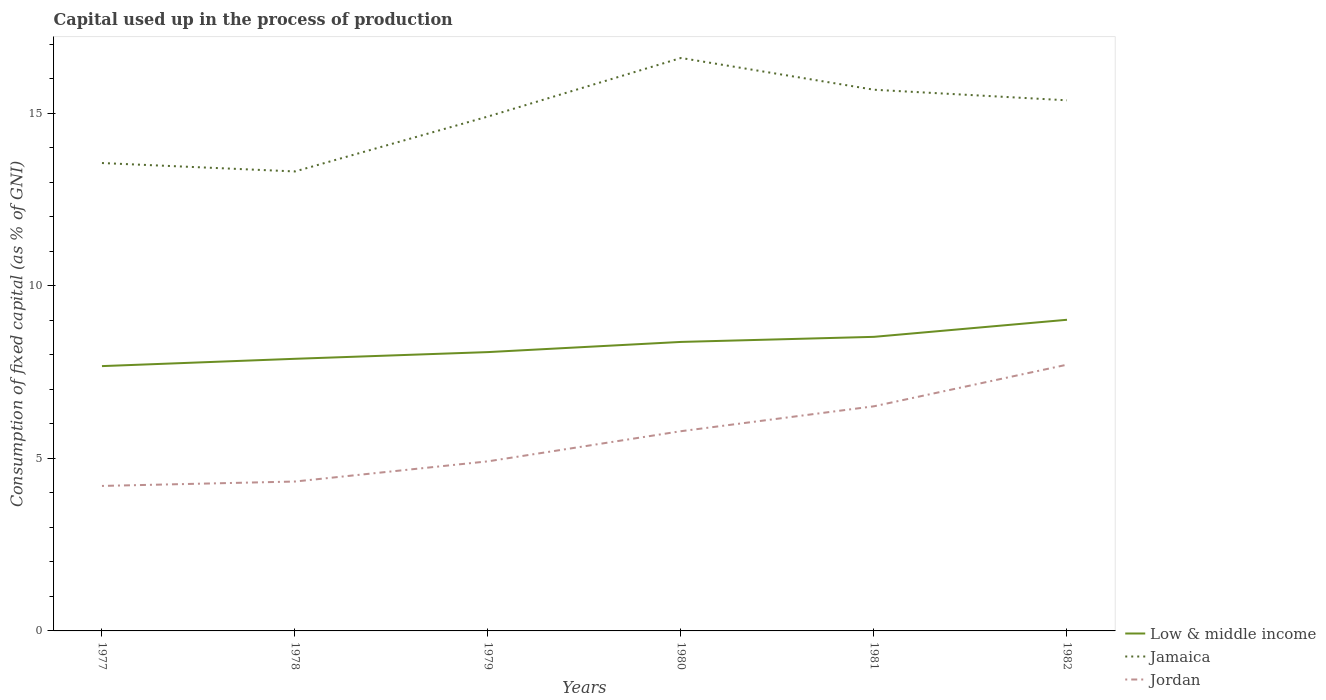Does the line corresponding to Jordan intersect with the line corresponding to Jamaica?
Your answer should be very brief. No. Across all years, what is the maximum capital used up in the process of production in Jamaica?
Offer a very short reply. 13.31. In which year was the capital used up in the process of production in Jamaica maximum?
Provide a succinct answer. 1978. What is the total capital used up in the process of production in Jordan in the graph?
Your answer should be very brief. -1.59. What is the difference between the highest and the second highest capital used up in the process of production in Low & middle income?
Provide a short and direct response. 1.34. What is the difference between the highest and the lowest capital used up in the process of production in Low & middle income?
Provide a succinct answer. 3. Is the capital used up in the process of production in Jamaica strictly greater than the capital used up in the process of production in Jordan over the years?
Provide a short and direct response. No. What is the difference between two consecutive major ticks on the Y-axis?
Provide a succinct answer. 5. Are the values on the major ticks of Y-axis written in scientific E-notation?
Provide a short and direct response. No. Does the graph contain grids?
Provide a short and direct response. No. Where does the legend appear in the graph?
Provide a succinct answer. Bottom right. How are the legend labels stacked?
Give a very brief answer. Vertical. What is the title of the graph?
Offer a very short reply. Capital used up in the process of production. Does "Thailand" appear as one of the legend labels in the graph?
Keep it short and to the point. No. What is the label or title of the X-axis?
Make the answer very short. Years. What is the label or title of the Y-axis?
Provide a short and direct response. Consumption of fixed capital (as % of GNI). What is the Consumption of fixed capital (as % of GNI) of Low & middle income in 1977?
Ensure brevity in your answer.  7.67. What is the Consumption of fixed capital (as % of GNI) in Jamaica in 1977?
Give a very brief answer. 13.55. What is the Consumption of fixed capital (as % of GNI) of Jordan in 1977?
Offer a very short reply. 4.2. What is the Consumption of fixed capital (as % of GNI) in Low & middle income in 1978?
Provide a short and direct response. 7.88. What is the Consumption of fixed capital (as % of GNI) in Jamaica in 1978?
Your response must be concise. 13.31. What is the Consumption of fixed capital (as % of GNI) of Jordan in 1978?
Your answer should be compact. 4.33. What is the Consumption of fixed capital (as % of GNI) in Low & middle income in 1979?
Your answer should be compact. 8.08. What is the Consumption of fixed capital (as % of GNI) of Jamaica in 1979?
Your answer should be compact. 14.9. What is the Consumption of fixed capital (as % of GNI) of Jordan in 1979?
Offer a very short reply. 4.91. What is the Consumption of fixed capital (as % of GNI) in Low & middle income in 1980?
Your answer should be very brief. 8.37. What is the Consumption of fixed capital (as % of GNI) of Jamaica in 1980?
Your answer should be very brief. 16.6. What is the Consumption of fixed capital (as % of GNI) of Jordan in 1980?
Ensure brevity in your answer.  5.79. What is the Consumption of fixed capital (as % of GNI) in Low & middle income in 1981?
Your response must be concise. 8.52. What is the Consumption of fixed capital (as % of GNI) of Jamaica in 1981?
Offer a terse response. 15.68. What is the Consumption of fixed capital (as % of GNI) of Jordan in 1981?
Provide a succinct answer. 6.51. What is the Consumption of fixed capital (as % of GNI) in Low & middle income in 1982?
Ensure brevity in your answer.  9.01. What is the Consumption of fixed capital (as % of GNI) of Jamaica in 1982?
Your response must be concise. 15.37. What is the Consumption of fixed capital (as % of GNI) of Jordan in 1982?
Your response must be concise. 7.71. Across all years, what is the maximum Consumption of fixed capital (as % of GNI) in Low & middle income?
Provide a short and direct response. 9.01. Across all years, what is the maximum Consumption of fixed capital (as % of GNI) of Jamaica?
Ensure brevity in your answer.  16.6. Across all years, what is the maximum Consumption of fixed capital (as % of GNI) of Jordan?
Your answer should be compact. 7.71. Across all years, what is the minimum Consumption of fixed capital (as % of GNI) of Low & middle income?
Your answer should be compact. 7.67. Across all years, what is the minimum Consumption of fixed capital (as % of GNI) of Jamaica?
Ensure brevity in your answer.  13.31. Across all years, what is the minimum Consumption of fixed capital (as % of GNI) in Jordan?
Make the answer very short. 4.2. What is the total Consumption of fixed capital (as % of GNI) of Low & middle income in the graph?
Your answer should be very brief. 49.53. What is the total Consumption of fixed capital (as % of GNI) in Jamaica in the graph?
Offer a very short reply. 89.41. What is the total Consumption of fixed capital (as % of GNI) in Jordan in the graph?
Offer a very short reply. 33.44. What is the difference between the Consumption of fixed capital (as % of GNI) of Low & middle income in 1977 and that in 1978?
Keep it short and to the point. -0.21. What is the difference between the Consumption of fixed capital (as % of GNI) of Jamaica in 1977 and that in 1978?
Provide a succinct answer. 0.24. What is the difference between the Consumption of fixed capital (as % of GNI) in Jordan in 1977 and that in 1978?
Provide a short and direct response. -0.13. What is the difference between the Consumption of fixed capital (as % of GNI) of Low & middle income in 1977 and that in 1979?
Offer a very short reply. -0.41. What is the difference between the Consumption of fixed capital (as % of GNI) of Jamaica in 1977 and that in 1979?
Make the answer very short. -1.35. What is the difference between the Consumption of fixed capital (as % of GNI) of Jordan in 1977 and that in 1979?
Make the answer very short. -0.71. What is the difference between the Consumption of fixed capital (as % of GNI) of Low & middle income in 1977 and that in 1980?
Your response must be concise. -0.7. What is the difference between the Consumption of fixed capital (as % of GNI) in Jamaica in 1977 and that in 1980?
Your answer should be compact. -3.04. What is the difference between the Consumption of fixed capital (as % of GNI) of Jordan in 1977 and that in 1980?
Your answer should be very brief. -1.59. What is the difference between the Consumption of fixed capital (as % of GNI) in Low & middle income in 1977 and that in 1981?
Keep it short and to the point. -0.85. What is the difference between the Consumption of fixed capital (as % of GNI) of Jamaica in 1977 and that in 1981?
Your answer should be compact. -2.12. What is the difference between the Consumption of fixed capital (as % of GNI) in Jordan in 1977 and that in 1981?
Make the answer very short. -2.31. What is the difference between the Consumption of fixed capital (as % of GNI) in Low & middle income in 1977 and that in 1982?
Your response must be concise. -1.34. What is the difference between the Consumption of fixed capital (as % of GNI) of Jamaica in 1977 and that in 1982?
Provide a short and direct response. -1.82. What is the difference between the Consumption of fixed capital (as % of GNI) in Jordan in 1977 and that in 1982?
Make the answer very short. -3.51. What is the difference between the Consumption of fixed capital (as % of GNI) in Low & middle income in 1978 and that in 1979?
Provide a succinct answer. -0.19. What is the difference between the Consumption of fixed capital (as % of GNI) in Jamaica in 1978 and that in 1979?
Keep it short and to the point. -1.59. What is the difference between the Consumption of fixed capital (as % of GNI) of Jordan in 1978 and that in 1979?
Offer a very short reply. -0.58. What is the difference between the Consumption of fixed capital (as % of GNI) in Low & middle income in 1978 and that in 1980?
Provide a succinct answer. -0.49. What is the difference between the Consumption of fixed capital (as % of GNI) of Jamaica in 1978 and that in 1980?
Provide a succinct answer. -3.29. What is the difference between the Consumption of fixed capital (as % of GNI) of Jordan in 1978 and that in 1980?
Provide a short and direct response. -1.46. What is the difference between the Consumption of fixed capital (as % of GNI) of Low & middle income in 1978 and that in 1981?
Give a very brief answer. -0.64. What is the difference between the Consumption of fixed capital (as % of GNI) in Jamaica in 1978 and that in 1981?
Make the answer very short. -2.37. What is the difference between the Consumption of fixed capital (as % of GNI) in Jordan in 1978 and that in 1981?
Your answer should be very brief. -2.18. What is the difference between the Consumption of fixed capital (as % of GNI) in Low & middle income in 1978 and that in 1982?
Offer a very short reply. -1.13. What is the difference between the Consumption of fixed capital (as % of GNI) in Jamaica in 1978 and that in 1982?
Offer a terse response. -2.06. What is the difference between the Consumption of fixed capital (as % of GNI) in Jordan in 1978 and that in 1982?
Your answer should be very brief. -3.38. What is the difference between the Consumption of fixed capital (as % of GNI) in Low & middle income in 1979 and that in 1980?
Offer a very short reply. -0.29. What is the difference between the Consumption of fixed capital (as % of GNI) in Jamaica in 1979 and that in 1980?
Your response must be concise. -1.7. What is the difference between the Consumption of fixed capital (as % of GNI) of Jordan in 1979 and that in 1980?
Provide a succinct answer. -0.87. What is the difference between the Consumption of fixed capital (as % of GNI) of Low & middle income in 1979 and that in 1981?
Your answer should be very brief. -0.44. What is the difference between the Consumption of fixed capital (as % of GNI) of Jamaica in 1979 and that in 1981?
Your answer should be very brief. -0.78. What is the difference between the Consumption of fixed capital (as % of GNI) in Jordan in 1979 and that in 1981?
Your answer should be compact. -1.59. What is the difference between the Consumption of fixed capital (as % of GNI) in Low & middle income in 1979 and that in 1982?
Provide a succinct answer. -0.94. What is the difference between the Consumption of fixed capital (as % of GNI) of Jamaica in 1979 and that in 1982?
Offer a very short reply. -0.47. What is the difference between the Consumption of fixed capital (as % of GNI) in Jordan in 1979 and that in 1982?
Keep it short and to the point. -2.8. What is the difference between the Consumption of fixed capital (as % of GNI) in Low & middle income in 1980 and that in 1981?
Offer a terse response. -0.15. What is the difference between the Consumption of fixed capital (as % of GNI) of Jamaica in 1980 and that in 1981?
Your response must be concise. 0.92. What is the difference between the Consumption of fixed capital (as % of GNI) of Jordan in 1980 and that in 1981?
Your answer should be compact. -0.72. What is the difference between the Consumption of fixed capital (as % of GNI) in Low & middle income in 1980 and that in 1982?
Make the answer very short. -0.64. What is the difference between the Consumption of fixed capital (as % of GNI) of Jamaica in 1980 and that in 1982?
Offer a terse response. 1.23. What is the difference between the Consumption of fixed capital (as % of GNI) in Jordan in 1980 and that in 1982?
Offer a terse response. -1.93. What is the difference between the Consumption of fixed capital (as % of GNI) of Low & middle income in 1981 and that in 1982?
Give a very brief answer. -0.49. What is the difference between the Consumption of fixed capital (as % of GNI) in Jamaica in 1981 and that in 1982?
Keep it short and to the point. 0.31. What is the difference between the Consumption of fixed capital (as % of GNI) in Jordan in 1981 and that in 1982?
Your answer should be compact. -1.21. What is the difference between the Consumption of fixed capital (as % of GNI) of Low & middle income in 1977 and the Consumption of fixed capital (as % of GNI) of Jamaica in 1978?
Your answer should be very brief. -5.64. What is the difference between the Consumption of fixed capital (as % of GNI) in Low & middle income in 1977 and the Consumption of fixed capital (as % of GNI) in Jordan in 1978?
Your answer should be very brief. 3.34. What is the difference between the Consumption of fixed capital (as % of GNI) in Jamaica in 1977 and the Consumption of fixed capital (as % of GNI) in Jordan in 1978?
Your response must be concise. 9.23. What is the difference between the Consumption of fixed capital (as % of GNI) in Low & middle income in 1977 and the Consumption of fixed capital (as % of GNI) in Jamaica in 1979?
Ensure brevity in your answer.  -7.23. What is the difference between the Consumption of fixed capital (as % of GNI) in Low & middle income in 1977 and the Consumption of fixed capital (as % of GNI) in Jordan in 1979?
Give a very brief answer. 2.76. What is the difference between the Consumption of fixed capital (as % of GNI) of Jamaica in 1977 and the Consumption of fixed capital (as % of GNI) of Jordan in 1979?
Make the answer very short. 8.64. What is the difference between the Consumption of fixed capital (as % of GNI) of Low & middle income in 1977 and the Consumption of fixed capital (as % of GNI) of Jamaica in 1980?
Make the answer very short. -8.93. What is the difference between the Consumption of fixed capital (as % of GNI) of Low & middle income in 1977 and the Consumption of fixed capital (as % of GNI) of Jordan in 1980?
Your response must be concise. 1.89. What is the difference between the Consumption of fixed capital (as % of GNI) of Jamaica in 1977 and the Consumption of fixed capital (as % of GNI) of Jordan in 1980?
Provide a succinct answer. 7.77. What is the difference between the Consumption of fixed capital (as % of GNI) in Low & middle income in 1977 and the Consumption of fixed capital (as % of GNI) in Jamaica in 1981?
Your answer should be compact. -8.01. What is the difference between the Consumption of fixed capital (as % of GNI) of Low & middle income in 1977 and the Consumption of fixed capital (as % of GNI) of Jordan in 1981?
Offer a very short reply. 1.16. What is the difference between the Consumption of fixed capital (as % of GNI) of Jamaica in 1977 and the Consumption of fixed capital (as % of GNI) of Jordan in 1981?
Ensure brevity in your answer.  7.05. What is the difference between the Consumption of fixed capital (as % of GNI) in Low & middle income in 1977 and the Consumption of fixed capital (as % of GNI) in Jamaica in 1982?
Keep it short and to the point. -7.7. What is the difference between the Consumption of fixed capital (as % of GNI) in Low & middle income in 1977 and the Consumption of fixed capital (as % of GNI) in Jordan in 1982?
Your answer should be compact. -0.04. What is the difference between the Consumption of fixed capital (as % of GNI) of Jamaica in 1977 and the Consumption of fixed capital (as % of GNI) of Jordan in 1982?
Provide a short and direct response. 5.84. What is the difference between the Consumption of fixed capital (as % of GNI) of Low & middle income in 1978 and the Consumption of fixed capital (as % of GNI) of Jamaica in 1979?
Offer a terse response. -7.02. What is the difference between the Consumption of fixed capital (as % of GNI) of Low & middle income in 1978 and the Consumption of fixed capital (as % of GNI) of Jordan in 1979?
Your answer should be very brief. 2.97. What is the difference between the Consumption of fixed capital (as % of GNI) of Jamaica in 1978 and the Consumption of fixed capital (as % of GNI) of Jordan in 1979?
Provide a short and direct response. 8.4. What is the difference between the Consumption of fixed capital (as % of GNI) in Low & middle income in 1978 and the Consumption of fixed capital (as % of GNI) in Jamaica in 1980?
Make the answer very short. -8.71. What is the difference between the Consumption of fixed capital (as % of GNI) in Low & middle income in 1978 and the Consumption of fixed capital (as % of GNI) in Jordan in 1980?
Ensure brevity in your answer.  2.1. What is the difference between the Consumption of fixed capital (as % of GNI) of Jamaica in 1978 and the Consumption of fixed capital (as % of GNI) of Jordan in 1980?
Ensure brevity in your answer.  7.52. What is the difference between the Consumption of fixed capital (as % of GNI) of Low & middle income in 1978 and the Consumption of fixed capital (as % of GNI) of Jamaica in 1981?
Provide a succinct answer. -7.79. What is the difference between the Consumption of fixed capital (as % of GNI) of Low & middle income in 1978 and the Consumption of fixed capital (as % of GNI) of Jordan in 1981?
Keep it short and to the point. 1.38. What is the difference between the Consumption of fixed capital (as % of GNI) in Jamaica in 1978 and the Consumption of fixed capital (as % of GNI) in Jordan in 1981?
Offer a very short reply. 6.8. What is the difference between the Consumption of fixed capital (as % of GNI) of Low & middle income in 1978 and the Consumption of fixed capital (as % of GNI) of Jamaica in 1982?
Ensure brevity in your answer.  -7.49. What is the difference between the Consumption of fixed capital (as % of GNI) of Low & middle income in 1978 and the Consumption of fixed capital (as % of GNI) of Jordan in 1982?
Provide a succinct answer. 0.17. What is the difference between the Consumption of fixed capital (as % of GNI) of Jamaica in 1978 and the Consumption of fixed capital (as % of GNI) of Jordan in 1982?
Provide a succinct answer. 5.6. What is the difference between the Consumption of fixed capital (as % of GNI) of Low & middle income in 1979 and the Consumption of fixed capital (as % of GNI) of Jamaica in 1980?
Your answer should be very brief. -8.52. What is the difference between the Consumption of fixed capital (as % of GNI) of Low & middle income in 1979 and the Consumption of fixed capital (as % of GNI) of Jordan in 1980?
Make the answer very short. 2.29. What is the difference between the Consumption of fixed capital (as % of GNI) in Jamaica in 1979 and the Consumption of fixed capital (as % of GNI) in Jordan in 1980?
Provide a short and direct response. 9.12. What is the difference between the Consumption of fixed capital (as % of GNI) of Low & middle income in 1979 and the Consumption of fixed capital (as % of GNI) of Jamaica in 1981?
Give a very brief answer. -7.6. What is the difference between the Consumption of fixed capital (as % of GNI) in Low & middle income in 1979 and the Consumption of fixed capital (as % of GNI) in Jordan in 1981?
Your response must be concise. 1.57. What is the difference between the Consumption of fixed capital (as % of GNI) in Jamaica in 1979 and the Consumption of fixed capital (as % of GNI) in Jordan in 1981?
Your response must be concise. 8.39. What is the difference between the Consumption of fixed capital (as % of GNI) in Low & middle income in 1979 and the Consumption of fixed capital (as % of GNI) in Jamaica in 1982?
Your response must be concise. -7.29. What is the difference between the Consumption of fixed capital (as % of GNI) of Low & middle income in 1979 and the Consumption of fixed capital (as % of GNI) of Jordan in 1982?
Provide a short and direct response. 0.36. What is the difference between the Consumption of fixed capital (as % of GNI) in Jamaica in 1979 and the Consumption of fixed capital (as % of GNI) in Jordan in 1982?
Your response must be concise. 7.19. What is the difference between the Consumption of fixed capital (as % of GNI) in Low & middle income in 1980 and the Consumption of fixed capital (as % of GNI) in Jamaica in 1981?
Your answer should be very brief. -7.31. What is the difference between the Consumption of fixed capital (as % of GNI) in Low & middle income in 1980 and the Consumption of fixed capital (as % of GNI) in Jordan in 1981?
Provide a short and direct response. 1.86. What is the difference between the Consumption of fixed capital (as % of GNI) in Jamaica in 1980 and the Consumption of fixed capital (as % of GNI) in Jordan in 1981?
Give a very brief answer. 10.09. What is the difference between the Consumption of fixed capital (as % of GNI) in Low & middle income in 1980 and the Consumption of fixed capital (as % of GNI) in Jamaica in 1982?
Provide a succinct answer. -7. What is the difference between the Consumption of fixed capital (as % of GNI) of Low & middle income in 1980 and the Consumption of fixed capital (as % of GNI) of Jordan in 1982?
Your answer should be very brief. 0.66. What is the difference between the Consumption of fixed capital (as % of GNI) in Jamaica in 1980 and the Consumption of fixed capital (as % of GNI) in Jordan in 1982?
Your response must be concise. 8.88. What is the difference between the Consumption of fixed capital (as % of GNI) in Low & middle income in 1981 and the Consumption of fixed capital (as % of GNI) in Jamaica in 1982?
Make the answer very short. -6.85. What is the difference between the Consumption of fixed capital (as % of GNI) in Low & middle income in 1981 and the Consumption of fixed capital (as % of GNI) in Jordan in 1982?
Provide a succinct answer. 0.81. What is the difference between the Consumption of fixed capital (as % of GNI) in Jamaica in 1981 and the Consumption of fixed capital (as % of GNI) in Jordan in 1982?
Your answer should be very brief. 7.96. What is the average Consumption of fixed capital (as % of GNI) in Low & middle income per year?
Provide a short and direct response. 8.26. What is the average Consumption of fixed capital (as % of GNI) in Jamaica per year?
Offer a terse response. 14.9. What is the average Consumption of fixed capital (as % of GNI) of Jordan per year?
Provide a succinct answer. 5.57. In the year 1977, what is the difference between the Consumption of fixed capital (as % of GNI) of Low & middle income and Consumption of fixed capital (as % of GNI) of Jamaica?
Your answer should be compact. -5.88. In the year 1977, what is the difference between the Consumption of fixed capital (as % of GNI) of Low & middle income and Consumption of fixed capital (as % of GNI) of Jordan?
Ensure brevity in your answer.  3.47. In the year 1977, what is the difference between the Consumption of fixed capital (as % of GNI) of Jamaica and Consumption of fixed capital (as % of GNI) of Jordan?
Give a very brief answer. 9.35. In the year 1978, what is the difference between the Consumption of fixed capital (as % of GNI) in Low & middle income and Consumption of fixed capital (as % of GNI) in Jamaica?
Provide a short and direct response. -5.43. In the year 1978, what is the difference between the Consumption of fixed capital (as % of GNI) of Low & middle income and Consumption of fixed capital (as % of GNI) of Jordan?
Your answer should be compact. 3.55. In the year 1978, what is the difference between the Consumption of fixed capital (as % of GNI) of Jamaica and Consumption of fixed capital (as % of GNI) of Jordan?
Provide a succinct answer. 8.98. In the year 1979, what is the difference between the Consumption of fixed capital (as % of GNI) in Low & middle income and Consumption of fixed capital (as % of GNI) in Jamaica?
Make the answer very short. -6.82. In the year 1979, what is the difference between the Consumption of fixed capital (as % of GNI) of Low & middle income and Consumption of fixed capital (as % of GNI) of Jordan?
Offer a terse response. 3.16. In the year 1979, what is the difference between the Consumption of fixed capital (as % of GNI) in Jamaica and Consumption of fixed capital (as % of GNI) in Jordan?
Your answer should be compact. 9.99. In the year 1980, what is the difference between the Consumption of fixed capital (as % of GNI) of Low & middle income and Consumption of fixed capital (as % of GNI) of Jamaica?
Make the answer very short. -8.23. In the year 1980, what is the difference between the Consumption of fixed capital (as % of GNI) in Low & middle income and Consumption of fixed capital (as % of GNI) in Jordan?
Keep it short and to the point. 2.59. In the year 1980, what is the difference between the Consumption of fixed capital (as % of GNI) of Jamaica and Consumption of fixed capital (as % of GNI) of Jordan?
Ensure brevity in your answer.  10.81. In the year 1981, what is the difference between the Consumption of fixed capital (as % of GNI) of Low & middle income and Consumption of fixed capital (as % of GNI) of Jamaica?
Your answer should be compact. -7.16. In the year 1981, what is the difference between the Consumption of fixed capital (as % of GNI) in Low & middle income and Consumption of fixed capital (as % of GNI) in Jordan?
Offer a terse response. 2.01. In the year 1981, what is the difference between the Consumption of fixed capital (as % of GNI) in Jamaica and Consumption of fixed capital (as % of GNI) in Jordan?
Your response must be concise. 9.17. In the year 1982, what is the difference between the Consumption of fixed capital (as % of GNI) of Low & middle income and Consumption of fixed capital (as % of GNI) of Jamaica?
Your answer should be very brief. -6.36. In the year 1982, what is the difference between the Consumption of fixed capital (as % of GNI) of Low & middle income and Consumption of fixed capital (as % of GNI) of Jordan?
Your answer should be very brief. 1.3. In the year 1982, what is the difference between the Consumption of fixed capital (as % of GNI) of Jamaica and Consumption of fixed capital (as % of GNI) of Jordan?
Offer a terse response. 7.66. What is the ratio of the Consumption of fixed capital (as % of GNI) of Low & middle income in 1977 to that in 1978?
Your answer should be very brief. 0.97. What is the ratio of the Consumption of fixed capital (as % of GNI) of Jamaica in 1977 to that in 1978?
Ensure brevity in your answer.  1.02. What is the ratio of the Consumption of fixed capital (as % of GNI) in Jordan in 1977 to that in 1978?
Your answer should be compact. 0.97. What is the ratio of the Consumption of fixed capital (as % of GNI) in Low & middle income in 1977 to that in 1979?
Your response must be concise. 0.95. What is the ratio of the Consumption of fixed capital (as % of GNI) of Jamaica in 1977 to that in 1979?
Give a very brief answer. 0.91. What is the ratio of the Consumption of fixed capital (as % of GNI) in Jordan in 1977 to that in 1979?
Your answer should be very brief. 0.85. What is the ratio of the Consumption of fixed capital (as % of GNI) in Low & middle income in 1977 to that in 1980?
Provide a short and direct response. 0.92. What is the ratio of the Consumption of fixed capital (as % of GNI) of Jamaica in 1977 to that in 1980?
Offer a terse response. 0.82. What is the ratio of the Consumption of fixed capital (as % of GNI) in Jordan in 1977 to that in 1980?
Your answer should be compact. 0.73. What is the ratio of the Consumption of fixed capital (as % of GNI) in Low & middle income in 1977 to that in 1981?
Offer a very short reply. 0.9. What is the ratio of the Consumption of fixed capital (as % of GNI) of Jamaica in 1977 to that in 1981?
Make the answer very short. 0.86. What is the ratio of the Consumption of fixed capital (as % of GNI) of Jordan in 1977 to that in 1981?
Your response must be concise. 0.65. What is the ratio of the Consumption of fixed capital (as % of GNI) in Low & middle income in 1977 to that in 1982?
Give a very brief answer. 0.85. What is the ratio of the Consumption of fixed capital (as % of GNI) of Jamaica in 1977 to that in 1982?
Offer a very short reply. 0.88. What is the ratio of the Consumption of fixed capital (as % of GNI) of Jordan in 1977 to that in 1982?
Your answer should be very brief. 0.54. What is the ratio of the Consumption of fixed capital (as % of GNI) in Low & middle income in 1978 to that in 1979?
Your answer should be very brief. 0.98. What is the ratio of the Consumption of fixed capital (as % of GNI) in Jamaica in 1978 to that in 1979?
Your answer should be very brief. 0.89. What is the ratio of the Consumption of fixed capital (as % of GNI) in Jordan in 1978 to that in 1979?
Provide a succinct answer. 0.88. What is the ratio of the Consumption of fixed capital (as % of GNI) of Low & middle income in 1978 to that in 1980?
Your response must be concise. 0.94. What is the ratio of the Consumption of fixed capital (as % of GNI) of Jamaica in 1978 to that in 1980?
Provide a short and direct response. 0.8. What is the ratio of the Consumption of fixed capital (as % of GNI) in Jordan in 1978 to that in 1980?
Make the answer very short. 0.75. What is the ratio of the Consumption of fixed capital (as % of GNI) of Low & middle income in 1978 to that in 1981?
Keep it short and to the point. 0.93. What is the ratio of the Consumption of fixed capital (as % of GNI) of Jamaica in 1978 to that in 1981?
Give a very brief answer. 0.85. What is the ratio of the Consumption of fixed capital (as % of GNI) in Jordan in 1978 to that in 1981?
Offer a terse response. 0.67. What is the ratio of the Consumption of fixed capital (as % of GNI) of Low & middle income in 1978 to that in 1982?
Offer a very short reply. 0.87. What is the ratio of the Consumption of fixed capital (as % of GNI) in Jamaica in 1978 to that in 1982?
Keep it short and to the point. 0.87. What is the ratio of the Consumption of fixed capital (as % of GNI) in Jordan in 1978 to that in 1982?
Your answer should be compact. 0.56. What is the ratio of the Consumption of fixed capital (as % of GNI) in Low & middle income in 1979 to that in 1980?
Your answer should be compact. 0.96. What is the ratio of the Consumption of fixed capital (as % of GNI) of Jamaica in 1979 to that in 1980?
Your answer should be very brief. 0.9. What is the ratio of the Consumption of fixed capital (as % of GNI) of Jordan in 1979 to that in 1980?
Ensure brevity in your answer.  0.85. What is the ratio of the Consumption of fixed capital (as % of GNI) in Low & middle income in 1979 to that in 1981?
Make the answer very short. 0.95. What is the ratio of the Consumption of fixed capital (as % of GNI) in Jamaica in 1979 to that in 1981?
Provide a short and direct response. 0.95. What is the ratio of the Consumption of fixed capital (as % of GNI) in Jordan in 1979 to that in 1981?
Your response must be concise. 0.76. What is the ratio of the Consumption of fixed capital (as % of GNI) in Low & middle income in 1979 to that in 1982?
Provide a short and direct response. 0.9. What is the ratio of the Consumption of fixed capital (as % of GNI) in Jamaica in 1979 to that in 1982?
Make the answer very short. 0.97. What is the ratio of the Consumption of fixed capital (as % of GNI) in Jordan in 1979 to that in 1982?
Offer a terse response. 0.64. What is the ratio of the Consumption of fixed capital (as % of GNI) in Low & middle income in 1980 to that in 1981?
Your response must be concise. 0.98. What is the ratio of the Consumption of fixed capital (as % of GNI) of Jamaica in 1980 to that in 1981?
Offer a terse response. 1.06. What is the ratio of the Consumption of fixed capital (as % of GNI) of Jordan in 1980 to that in 1981?
Provide a short and direct response. 0.89. What is the ratio of the Consumption of fixed capital (as % of GNI) in Low & middle income in 1980 to that in 1982?
Ensure brevity in your answer.  0.93. What is the ratio of the Consumption of fixed capital (as % of GNI) in Jamaica in 1980 to that in 1982?
Your answer should be compact. 1.08. What is the ratio of the Consumption of fixed capital (as % of GNI) in Jordan in 1980 to that in 1982?
Provide a succinct answer. 0.75. What is the ratio of the Consumption of fixed capital (as % of GNI) in Low & middle income in 1981 to that in 1982?
Provide a short and direct response. 0.95. What is the ratio of the Consumption of fixed capital (as % of GNI) of Jordan in 1981 to that in 1982?
Make the answer very short. 0.84. What is the difference between the highest and the second highest Consumption of fixed capital (as % of GNI) of Low & middle income?
Make the answer very short. 0.49. What is the difference between the highest and the second highest Consumption of fixed capital (as % of GNI) in Jamaica?
Your answer should be compact. 0.92. What is the difference between the highest and the second highest Consumption of fixed capital (as % of GNI) of Jordan?
Your response must be concise. 1.21. What is the difference between the highest and the lowest Consumption of fixed capital (as % of GNI) of Low & middle income?
Your answer should be compact. 1.34. What is the difference between the highest and the lowest Consumption of fixed capital (as % of GNI) of Jamaica?
Your answer should be very brief. 3.29. What is the difference between the highest and the lowest Consumption of fixed capital (as % of GNI) of Jordan?
Your response must be concise. 3.51. 